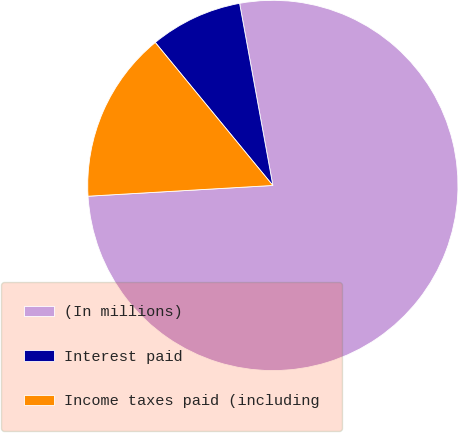<chart> <loc_0><loc_0><loc_500><loc_500><pie_chart><fcel>(In millions)<fcel>Interest paid<fcel>Income taxes paid (including<nl><fcel>76.95%<fcel>8.08%<fcel>14.97%<nl></chart> 